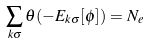<formula> <loc_0><loc_0><loc_500><loc_500>\sum _ { k \sigma } \theta ( - E _ { k \sigma } [ \phi ] ) = N _ { e }</formula> 